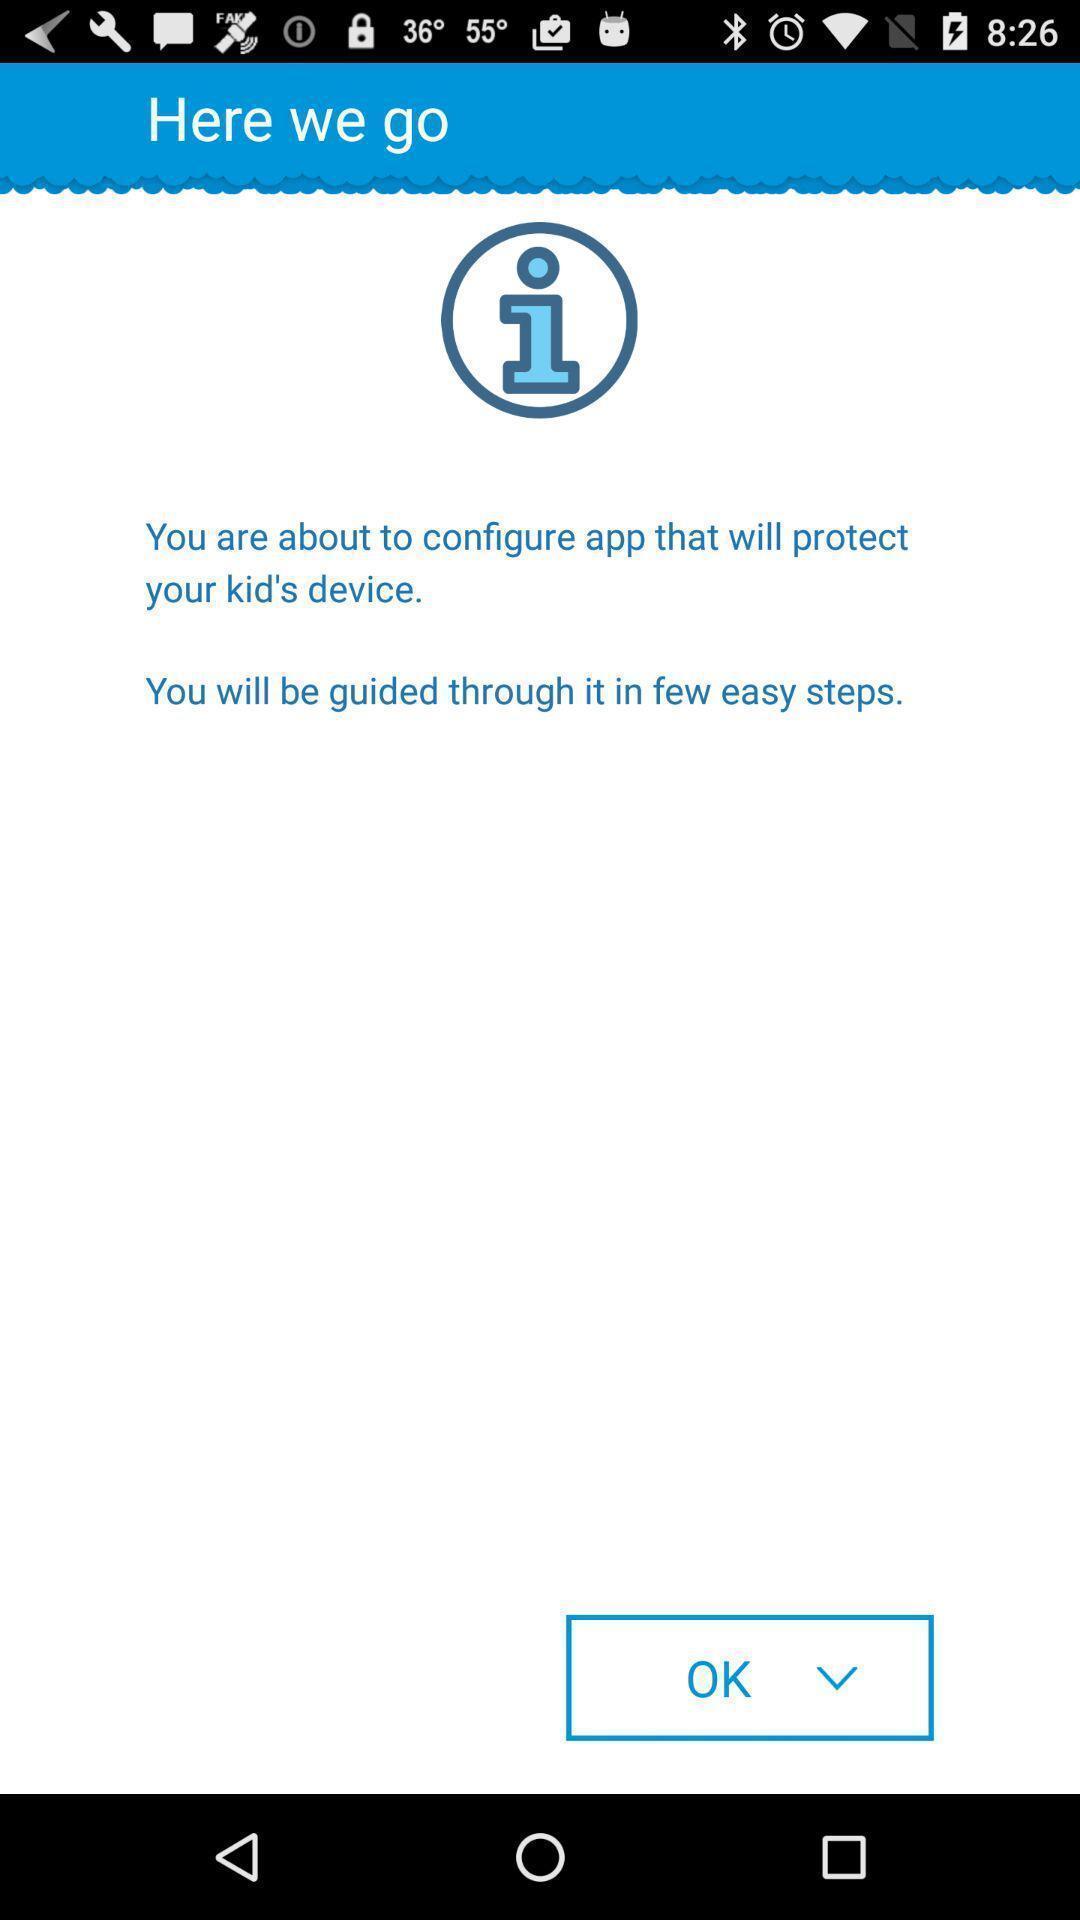What can you discern from this picture? Page displaying information on an app. 